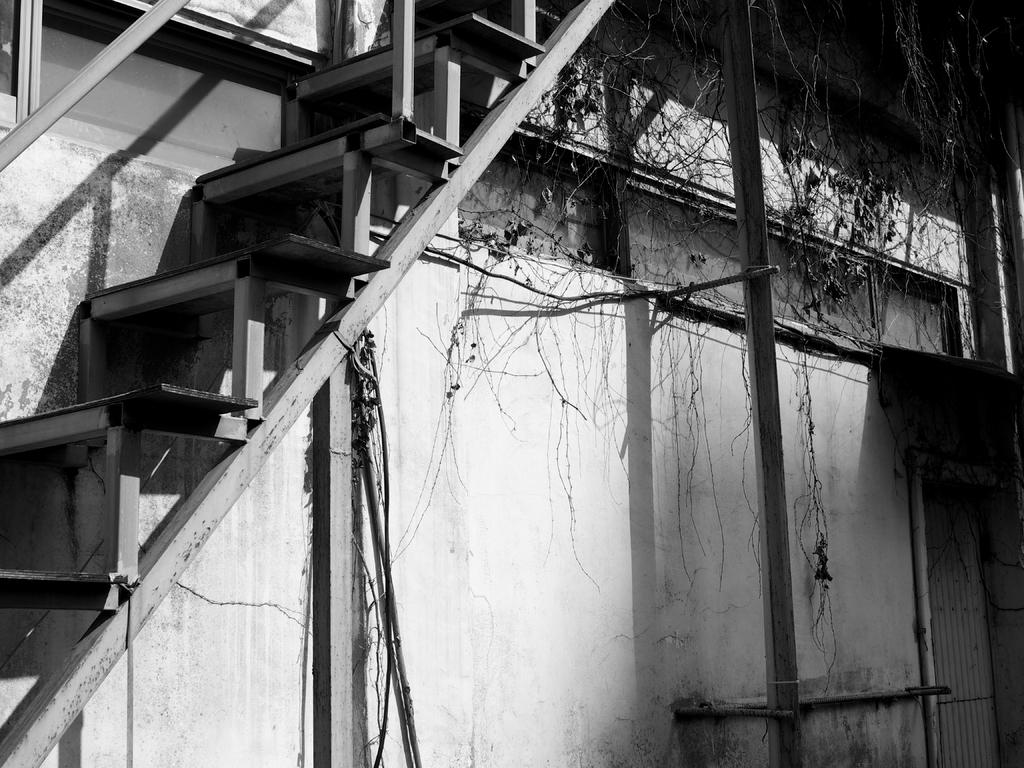What is the color scheme of the image? The image is black and white. What can be seen in the image that people use to move between different levels? There are stairs in the image. What is visible in the background of the image? There is a wall in the background of the image. What type of balls are being used to mine coal in the image? There is no reference to balls or coal mining in the image; it features stairs and a wall. What type of road can be seen in the image? There is no road present in the image. 